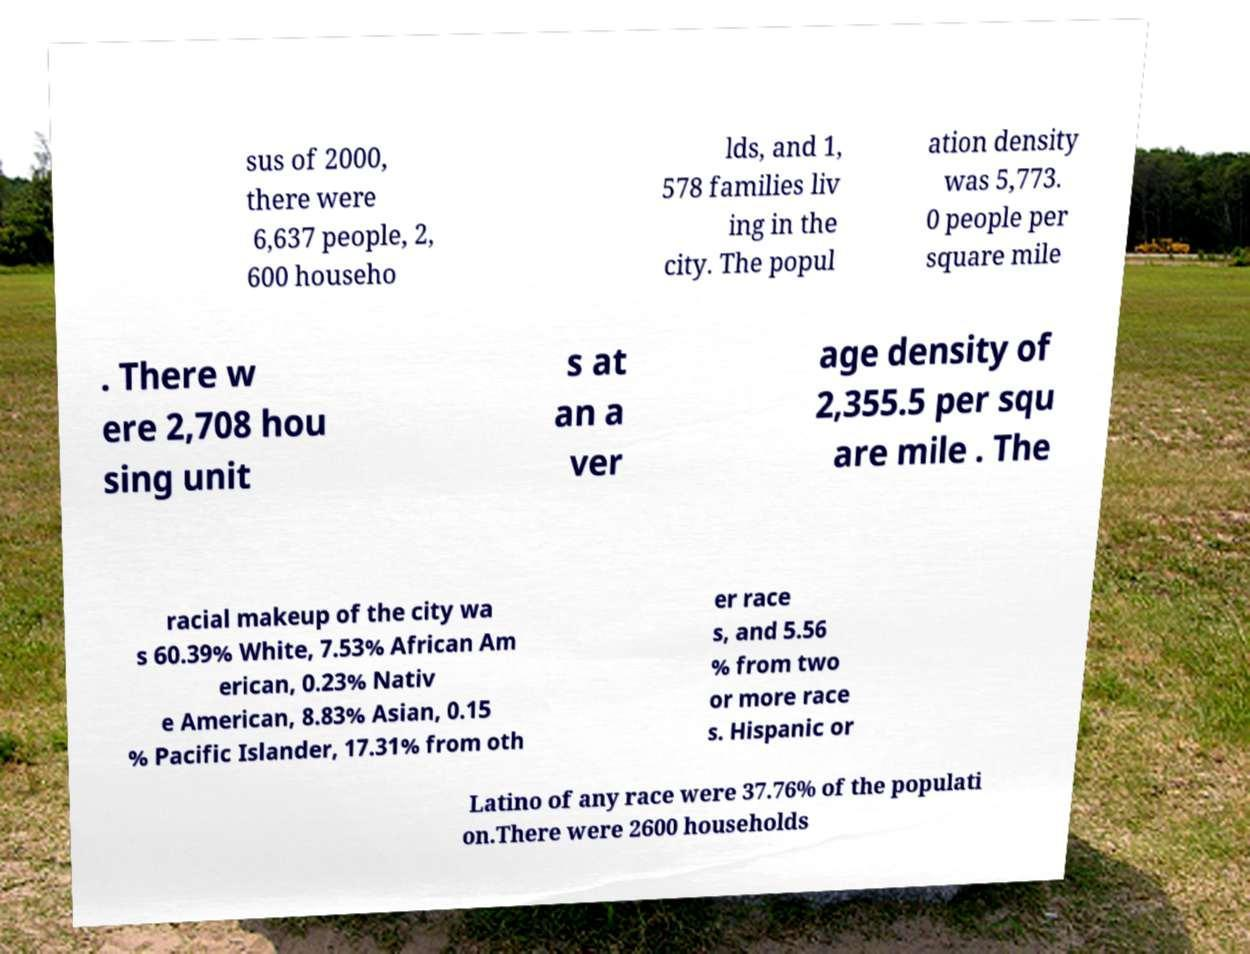I need the written content from this picture converted into text. Can you do that? sus of 2000, there were 6,637 people, 2, 600 househo lds, and 1, 578 families liv ing in the city. The popul ation density was 5,773. 0 people per square mile . There w ere 2,708 hou sing unit s at an a ver age density of 2,355.5 per squ are mile . The racial makeup of the city wa s 60.39% White, 7.53% African Am erican, 0.23% Nativ e American, 8.83% Asian, 0.15 % Pacific Islander, 17.31% from oth er race s, and 5.56 % from two or more race s. Hispanic or Latino of any race were 37.76% of the populati on.There were 2600 households 